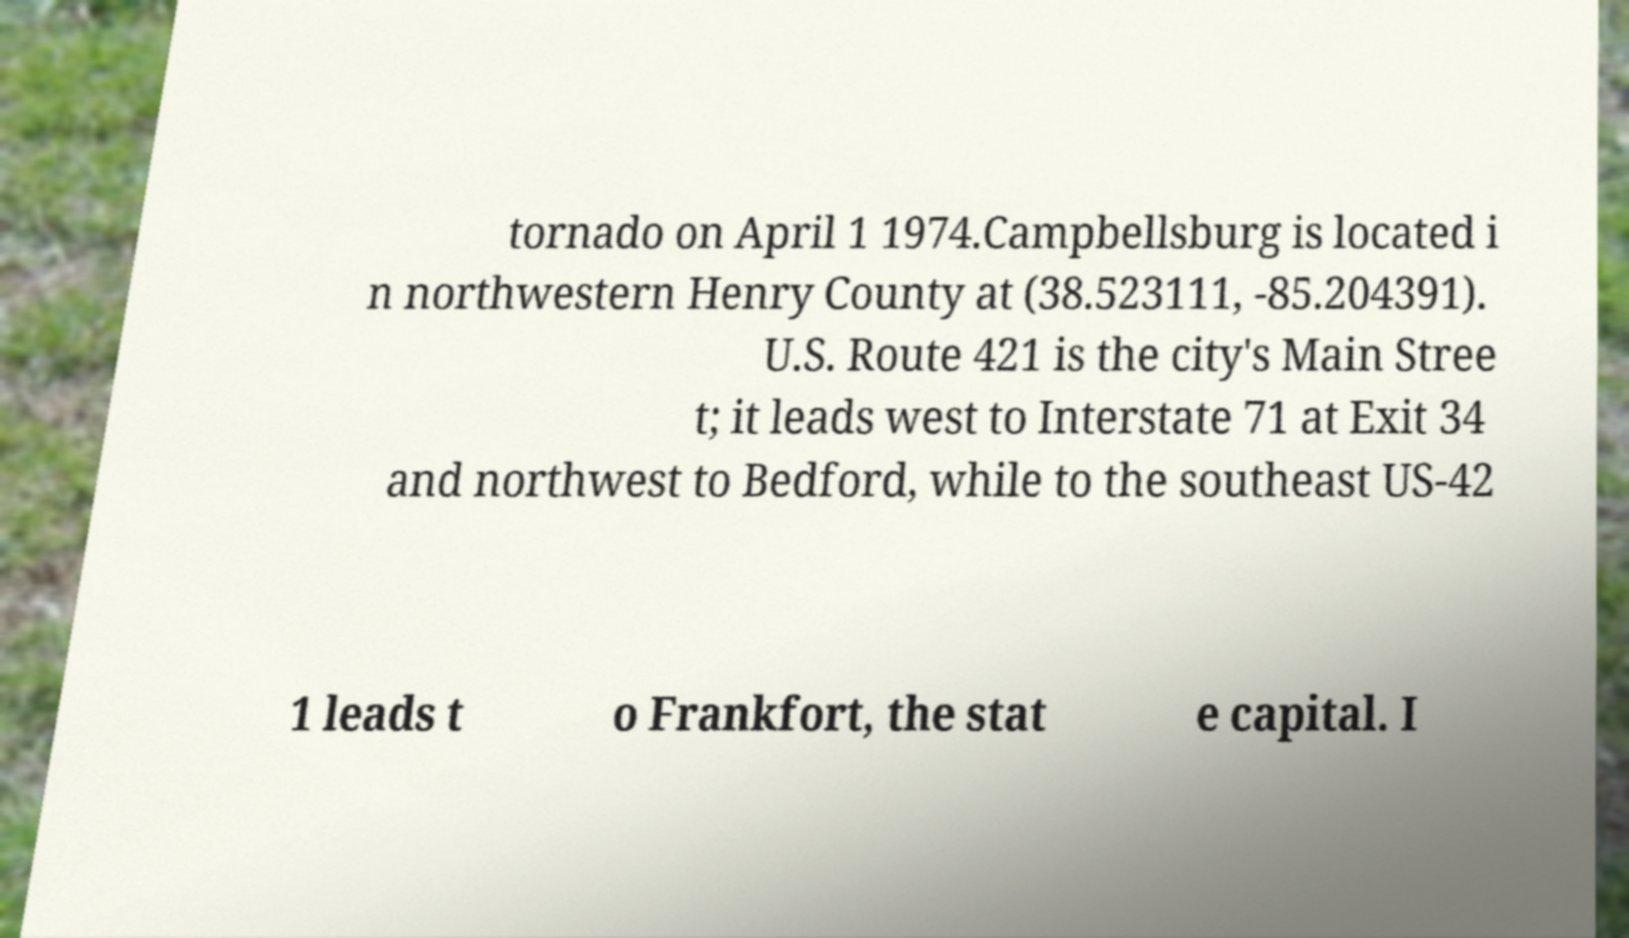Could you assist in decoding the text presented in this image and type it out clearly? tornado on April 1 1974.Campbellsburg is located i n northwestern Henry County at (38.523111, -85.204391). U.S. Route 421 is the city's Main Stree t; it leads west to Interstate 71 at Exit 34 and northwest to Bedford, while to the southeast US-42 1 leads t o Frankfort, the stat e capital. I 